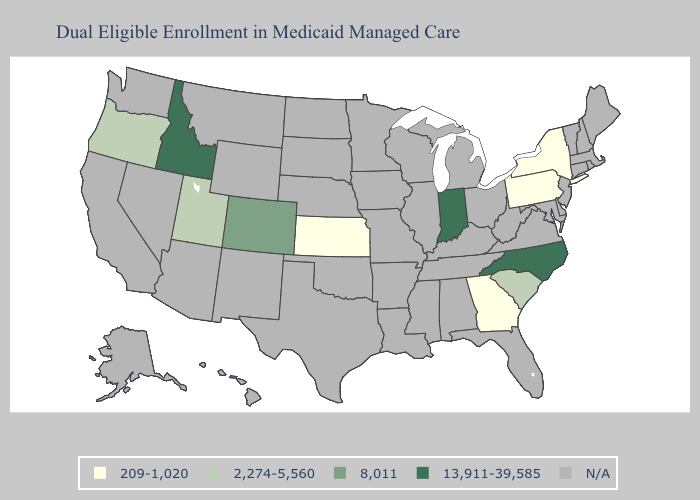What is the lowest value in the USA?
Give a very brief answer. 209-1,020. Name the states that have a value in the range 13,911-39,585?
Give a very brief answer. Idaho, Indiana, North Carolina. What is the highest value in the West ?
Answer briefly. 13,911-39,585. Which states have the highest value in the USA?
Be succinct. Idaho, Indiana, North Carolina. What is the highest value in the MidWest ?
Quick response, please. 13,911-39,585. Name the states that have a value in the range 2,274-5,560?
Answer briefly. Oregon, South Carolina, Utah. Among the states that border Tennessee , which have the highest value?
Concise answer only. North Carolina. What is the value of Nevada?
Give a very brief answer. N/A. What is the value of New York?
Write a very short answer. 209-1,020. Which states have the lowest value in the South?
Answer briefly. Georgia. What is the lowest value in states that border Virginia?
Give a very brief answer. 13,911-39,585. Name the states that have a value in the range 2,274-5,560?
Answer briefly. Oregon, South Carolina, Utah. Does the map have missing data?
Answer briefly. Yes. What is the highest value in the West ?
Concise answer only. 13,911-39,585. 